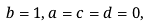<formula> <loc_0><loc_0><loc_500><loc_500>b = 1 , a = c = d = 0 ,</formula> 